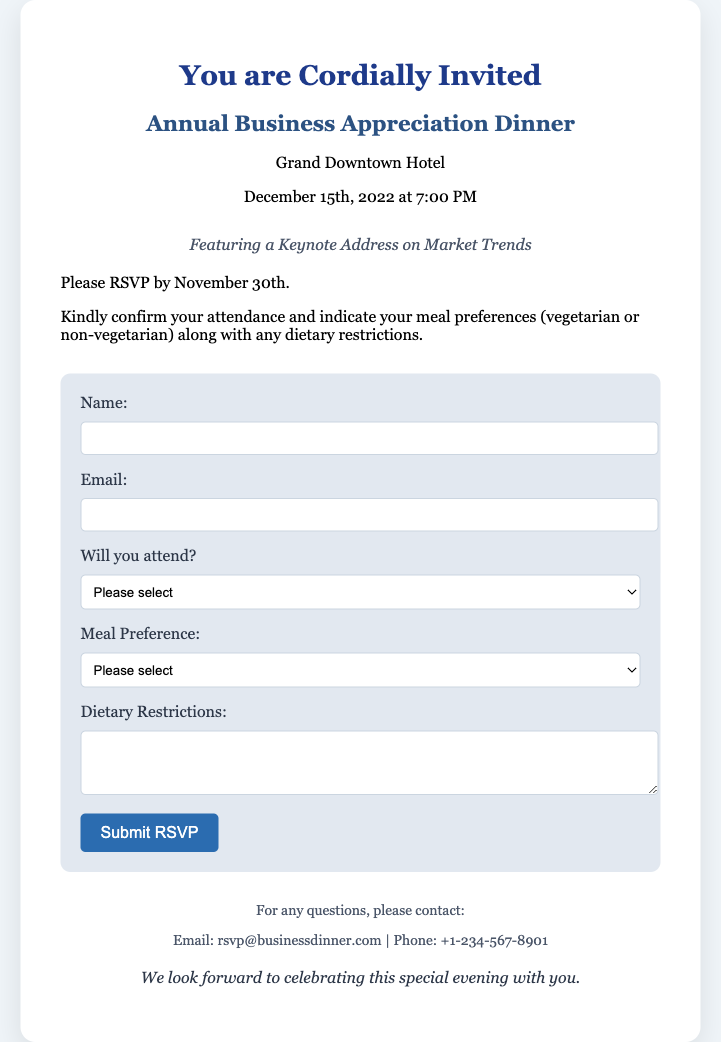What is the date of the dinner? The date of the dinner is explicitly mentioned in the card.
Answer: December 15th, 2022 What time does the event start? The starting time for the event is provided in the event details section.
Answer: 7:00 PM Where is the dinner being held? The location is specified in the document under event details.
Answer: Grand Downtown Hotel What is the RSVP deadline? The deadline for RSVPs is clearly stated in the instructions section.
Answer: November 30th What meal options are available? The document lists the meal preferences that attendees can select from.
Answer: Vegetarian or non-vegetarian What type of address will be featured during the event? The document mentions the type of address included in the event's agenda.
Answer: Keynote address on market trends What should attendees include in their RSVP? The RSVP requires specific information to be provided by the attendees.
Answer: Meal preferences and dietary restrictions Who should questions be directed to? The document provides contact information for inquiries about the event.
Answer: rsvp@businessdinner.com How can attendees confirm their attendance? Instructions on how to RSVP and confirm attendance are given in the document.
Answer: By completing the RSVP form 